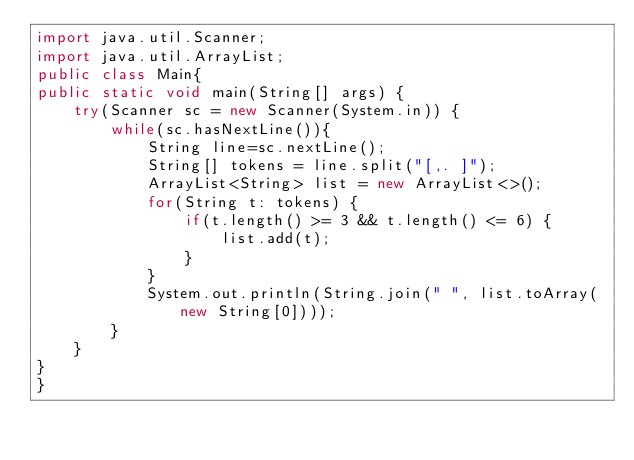Convert code to text. <code><loc_0><loc_0><loc_500><loc_500><_Java_>import java.util.Scanner;
import java.util.ArrayList;
public class Main{
public static void main(String[] args) {
    try(Scanner sc = new Scanner(System.in)) {
        while(sc.hasNextLine()){
            String line=sc.nextLine();
            String[] tokens = line.split("[,. ]");
            ArrayList<String> list = new ArrayList<>();
            for(String t: tokens) {
                if(t.length() >= 3 && t.length() <= 6) {
                    list.add(t);
                }
            }
            System.out.println(String.join(" ", list.toArray(new String[0])));
        }
    }
}
}
</code> 